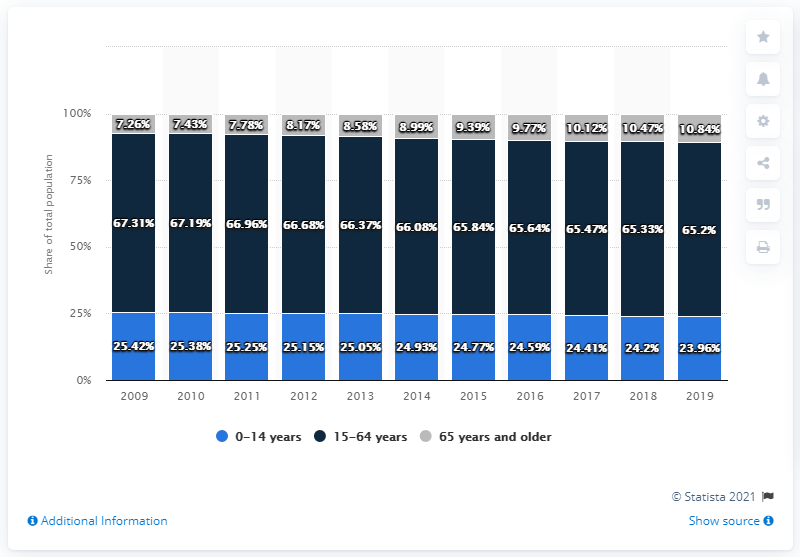Draw attention to some important aspects in this diagram. In the years 2013 and 2015, the total number of shares among individuals aged 0-14 was approximately 0.28. In 2019, the age group of 65 years and older had a high share. 